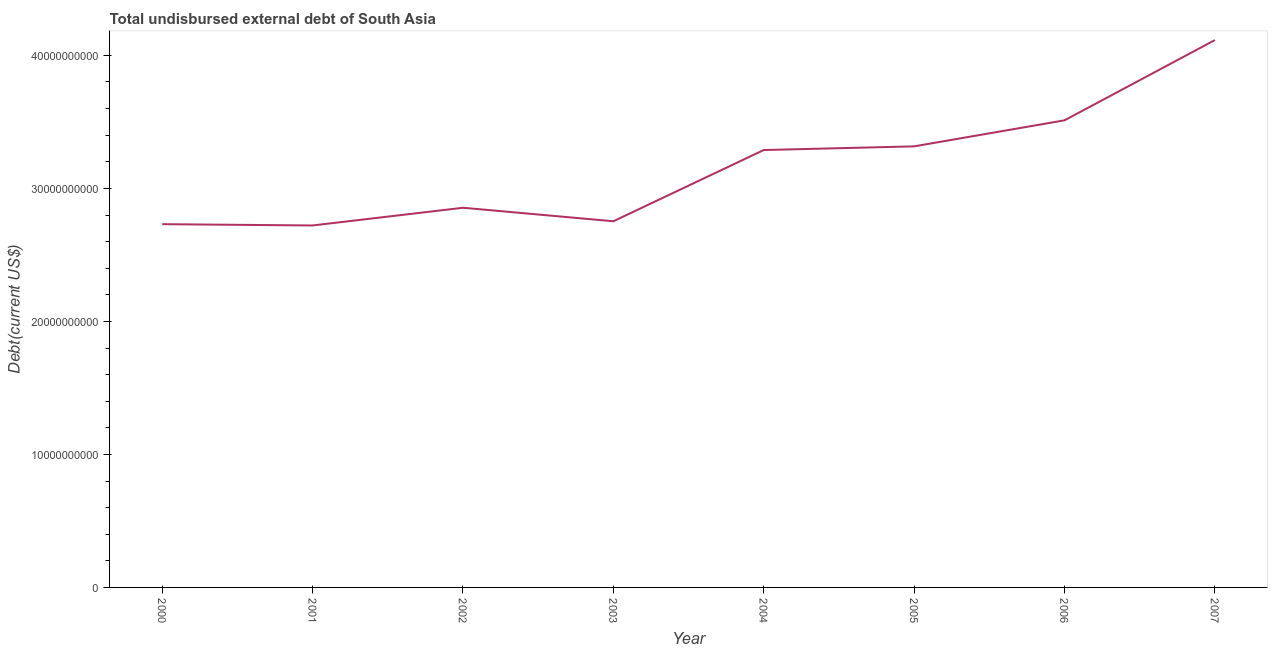What is the total debt in 2006?
Provide a short and direct response. 3.51e+1. Across all years, what is the maximum total debt?
Your answer should be very brief. 4.12e+1. Across all years, what is the minimum total debt?
Your answer should be very brief. 2.72e+1. In which year was the total debt maximum?
Give a very brief answer. 2007. In which year was the total debt minimum?
Ensure brevity in your answer.  2001. What is the sum of the total debt?
Your answer should be very brief. 2.53e+11. What is the difference between the total debt in 2004 and 2006?
Provide a succinct answer. -2.23e+09. What is the average total debt per year?
Give a very brief answer. 3.16e+1. What is the median total debt?
Provide a short and direct response. 3.07e+1. What is the ratio of the total debt in 2001 to that in 2006?
Provide a short and direct response. 0.77. Is the total debt in 2001 less than that in 2005?
Your answer should be compact. Yes. Is the difference between the total debt in 2000 and 2004 greater than the difference between any two years?
Your answer should be very brief. No. What is the difference between the highest and the second highest total debt?
Keep it short and to the point. 6.03e+09. What is the difference between the highest and the lowest total debt?
Offer a very short reply. 1.39e+1. Does the total debt monotonically increase over the years?
Offer a terse response. No. How many years are there in the graph?
Offer a terse response. 8. What is the difference between two consecutive major ticks on the Y-axis?
Provide a succinct answer. 1.00e+1. What is the title of the graph?
Ensure brevity in your answer.  Total undisbursed external debt of South Asia. What is the label or title of the X-axis?
Give a very brief answer. Year. What is the label or title of the Y-axis?
Your response must be concise. Debt(current US$). What is the Debt(current US$) of 2000?
Your response must be concise. 2.73e+1. What is the Debt(current US$) of 2001?
Your answer should be very brief. 2.72e+1. What is the Debt(current US$) in 2002?
Offer a very short reply. 2.85e+1. What is the Debt(current US$) in 2003?
Ensure brevity in your answer.  2.75e+1. What is the Debt(current US$) of 2004?
Ensure brevity in your answer.  3.29e+1. What is the Debt(current US$) of 2005?
Provide a succinct answer. 3.32e+1. What is the Debt(current US$) in 2006?
Offer a terse response. 3.51e+1. What is the Debt(current US$) in 2007?
Offer a terse response. 4.12e+1. What is the difference between the Debt(current US$) in 2000 and 2001?
Make the answer very short. 9.77e+07. What is the difference between the Debt(current US$) in 2000 and 2002?
Provide a succinct answer. -1.23e+09. What is the difference between the Debt(current US$) in 2000 and 2003?
Your response must be concise. -2.19e+08. What is the difference between the Debt(current US$) in 2000 and 2004?
Keep it short and to the point. -5.57e+09. What is the difference between the Debt(current US$) in 2000 and 2005?
Your answer should be very brief. -5.85e+09. What is the difference between the Debt(current US$) in 2000 and 2006?
Make the answer very short. -7.81e+09. What is the difference between the Debt(current US$) in 2000 and 2007?
Your answer should be very brief. -1.38e+1. What is the difference between the Debt(current US$) in 2001 and 2002?
Your answer should be very brief. -1.33e+09. What is the difference between the Debt(current US$) in 2001 and 2003?
Your answer should be very brief. -3.16e+08. What is the difference between the Debt(current US$) in 2001 and 2004?
Your answer should be compact. -5.67e+09. What is the difference between the Debt(current US$) in 2001 and 2005?
Keep it short and to the point. -5.95e+09. What is the difference between the Debt(current US$) in 2001 and 2006?
Provide a succinct answer. -7.90e+09. What is the difference between the Debt(current US$) in 2001 and 2007?
Offer a terse response. -1.39e+1. What is the difference between the Debt(current US$) in 2002 and 2003?
Your response must be concise. 1.02e+09. What is the difference between the Debt(current US$) in 2002 and 2004?
Provide a short and direct response. -4.34e+09. What is the difference between the Debt(current US$) in 2002 and 2005?
Make the answer very short. -4.62e+09. What is the difference between the Debt(current US$) in 2002 and 2006?
Your answer should be very brief. -6.57e+09. What is the difference between the Debt(current US$) in 2002 and 2007?
Provide a succinct answer. -1.26e+1. What is the difference between the Debt(current US$) in 2003 and 2004?
Make the answer very short. -5.35e+09. What is the difference between the Debt(current US$) in 2003 and 2005?
Your answer should be compact. -5.63e+09. What is the difference between the Debt(current US$) in 2003 and 2006?
Your answer should be very brief. -7.59e+09. What is the difference between the Debt(current US$) in 2003 and 2007?
Keep it short and to the point. -1.36e+1. What is the difference between the Debt(current US$) in 2004 and 2005?
Give a very brief answer. -2.76e+08. What is the difference between the Debt(current US$) in 2004 and 2006?
Provide a succinct answer. -2.23e+09. What is the difference between the Debt(current US$) in 2004 and 2007?
Your response must be concise. -8.27e+09. What is the difference between the Debt(current US$) in 2005 and 2006?
Your answer should be compact. -1.96e+09. What is the difference between the Debt(current US$) in 2005 and 2007?
Provide a short and direct response. -7.99e+09. What is the difference between the Debt(current US$) in 2006 and 2007?
Give a very brief answer. -6.03e+09. What is the ratio of the Debt(current US$) in 2000 to that in 2004?
Your response must be concise. 0.83. What is the ratio of the Debt(current US$) in 2000 to that in 2005?
Your answer should be compact. 0.82. What is the ratio of the Debt(current US$) in 2000 to that in 2006?
Offer a very short reply. 0.78. What is the ratio of the Debt(current US$) in 2000 to that in 2007?
Your answer should be very brief. 0.66. What is the ratio of the Debt(current US$) in 2001 to that in 2002?
Your answer should be compact. 0.95. What is the ratio of the Debt(current US$) in 2001 to that in 2003?
Provide a succinct answer. 0.99. What is the ratio of the Debt(current US$) in 2001 to that in 2004?
Give a very brief answer. 0.83. What is the ratio of the Debt(current US$) in 2001 to that in 2005?
Make the answer very short. 0.82. What is the ratio of the Debt(current US$) in 2001 to that in 2006?
Keep it short and to the point. 0.78. What is the ratio of the Debt(current US$) in 2001 to that in 2007?
Give a very brief answer. 0.66. What is the ratio of the Debt(current US$) in 2002 to that in 2004?
Keep it short and to the point. 0.87. What is the ratio of the Debt(current US$) in 2002 to that in 2005?
Your answer should be compact. 0.86. What is the ratio of the Debt(current US$) in 2002 to that in 2006?
Make the answer very short. 0.81. What is the ratio of the Debt(current US$) in 2002 to that in 2007?
Keep it short and to the point. 0.69. What is the ratio of the Debt(current US$) in 2003 to that in 2004?
Your answer should be very brief. 0.84. What is the ratio of the Debt(current US$) in 2003 to that in 2005?
Keep it short and to the point. 0.83. What is the ratio of the Debt(current US$) in 2003 to that in 2006?
Your answer should be compact. 0.78. What is the ratio of the Debt(current US$) in 2003 to that in 2007?
Keep it short and to the point. 0.67. What is the ratio of the Debt(current US$) in 2004 to that in 2005?
Your answer should be compact. 0.99. What is the ratio of the Debt(current US$) in 2004 to that in 2006?
Your response must be concise. 0.94. What is the ratio of the Debt(current US$) in 2004 to that in 2007?
Give a very brief answer. 0.8. What is the ratio of the Debt(current US$) in 2005 to that in 2006?
Provide a succinct answer. 0.94. What is the ratio of the Debt(current US$) in 2005 to that in 2007?
Provide a short and direct response. 0.81. What is the ratio of the Debt(current US$) in 2006 to that in 2007?
Give a very brief answer. 0.85. 